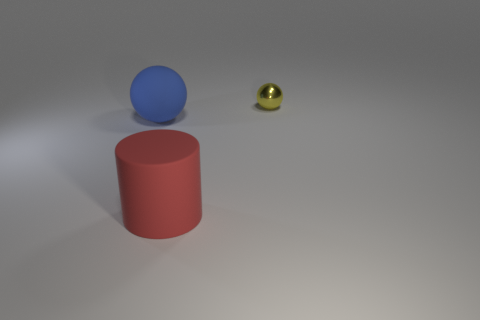Add 2 big red things. How many objects exist? 5 Subtract 1 balls. How many balls are left? 1 Add 1 small metallic spheres. How many small metallic spheres are left? 2 Add 3 yellow shiny things. How many yellow shiny things exist? 4 Subtract 0 cyan cylinders. How many objects are left? 3 Subtract all cylinders. How many objects are left? 2 Subtract all brown cylinders. Subtract all brown spheres. How many cylinders are left? 1 Subtract all red cylinders. How many blue balls are left? 1 Subtract all small blue shiny cylinders. Subtract all red matte things. How many objects are left? 2 